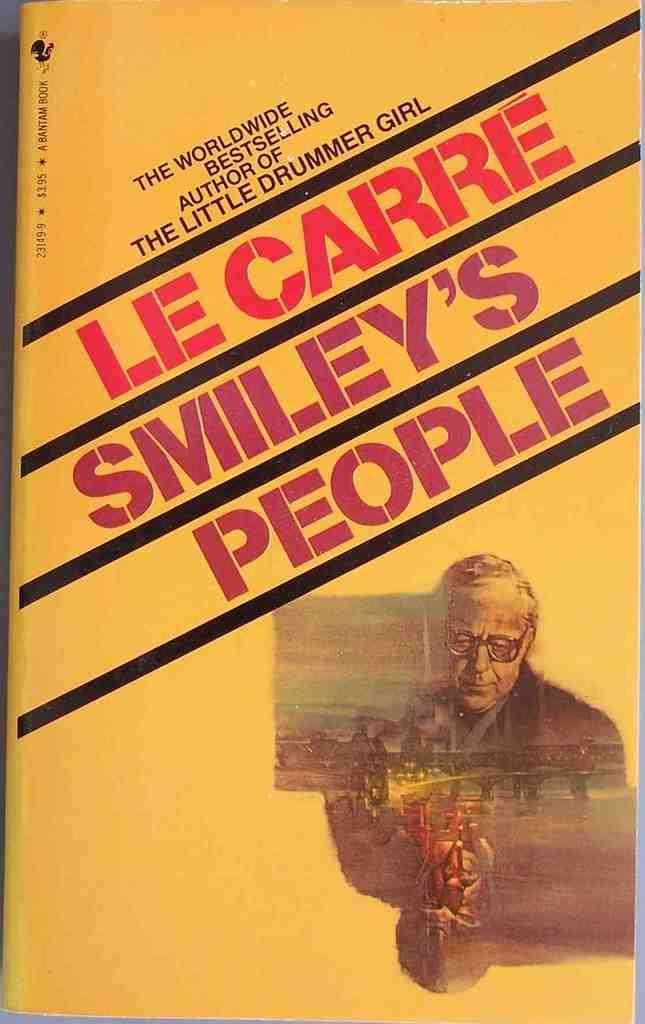<image>
Present a compact description of the photo's key features. The book Smiley's People is by the same bestselling author wrote The Little Drummer Girl. 